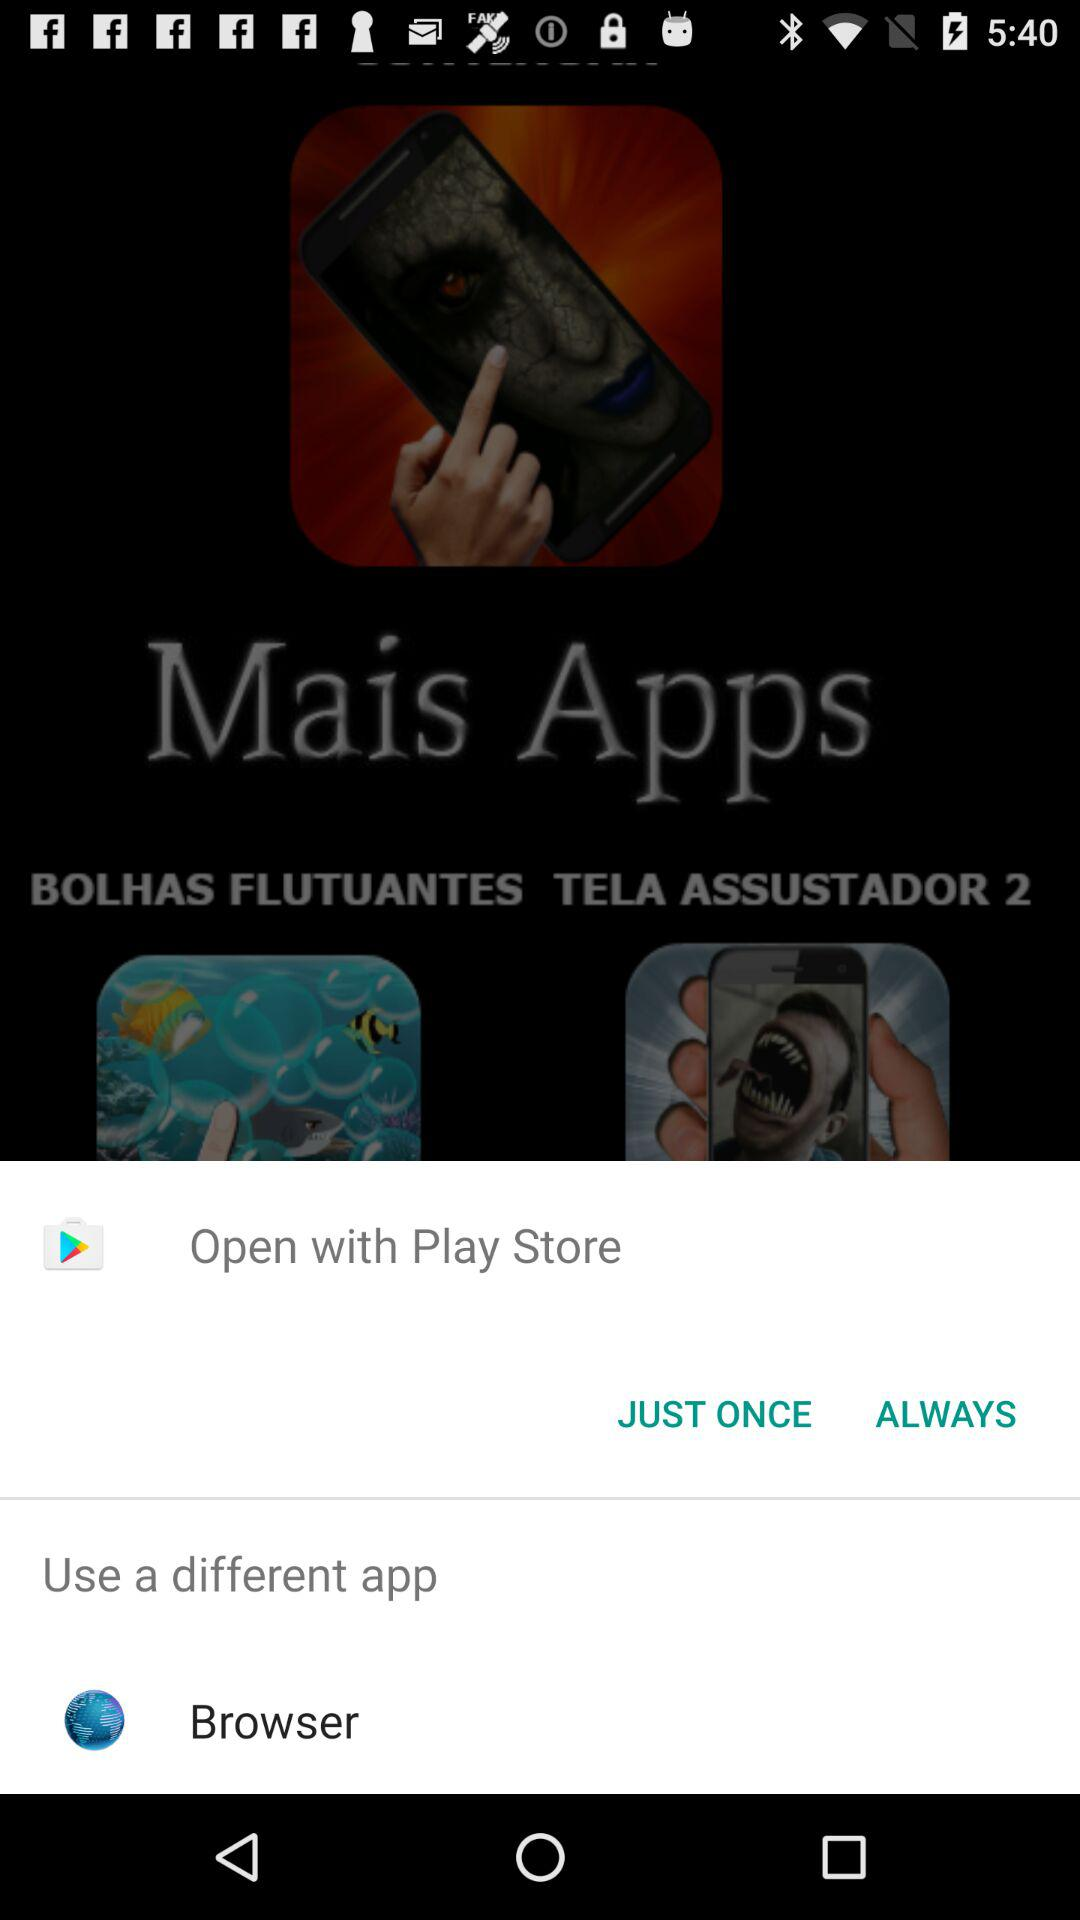Which application can I use to open the content? To open the content, you can use "Play Store" and "Browser". 